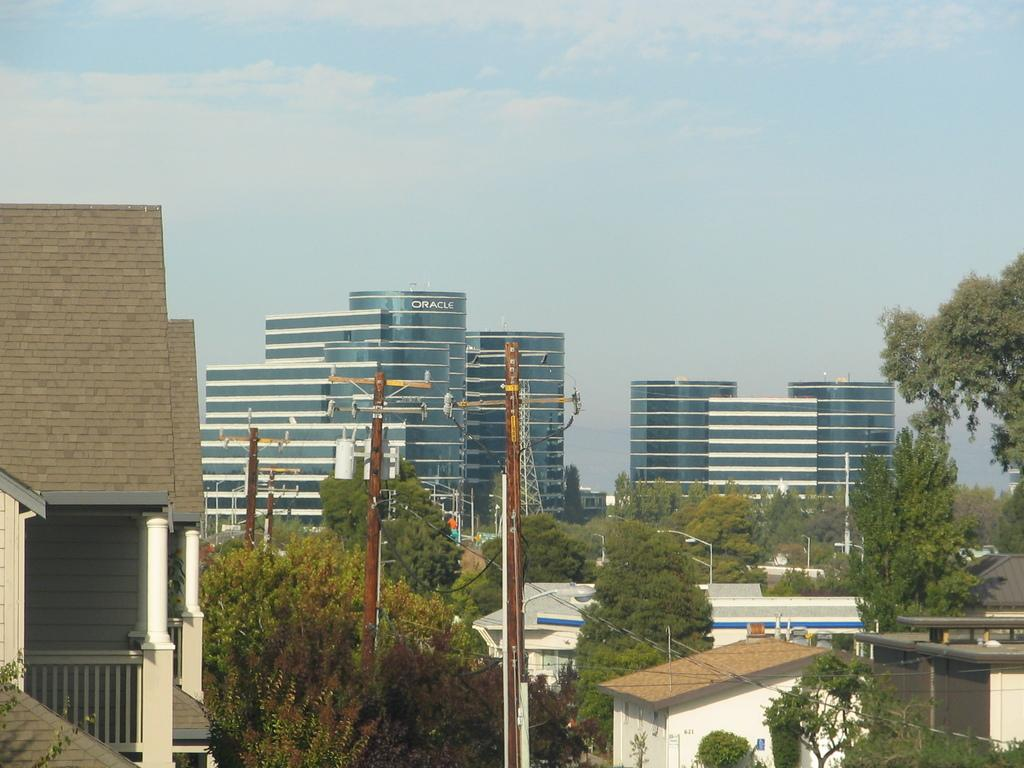<image>
Create a compact narrative representing the image presented. A view of buildings in the distance including an Oracle building 